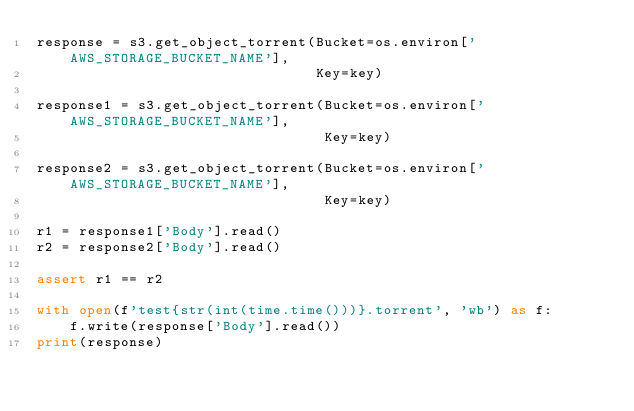<code> <loc_0><loc_0><loc_500><loc_500><_Python_>response = s3.get_object_torrent(Bucket=os.environ['AWS_STORAGE_BUCKET_NAME'],
                                 Key=key)

response1 = s3.get_object_torrent(Bucket=os.environ['AWS_STORAGE_BUCKET_NAME'],
                                  Key=key)

response2 = s3.get_object_torrent(Bucket=os.environ['AWS_STORAGE_BUCKET_NAME'],
                                  Key=key)

r1 = response1['Body'].read()
r2 = response2['Body'].read()

assert r1 == r2

with open(f'test{str(int(time.time()))}.torrent', 'wb') as f:
    f.write(response['Body'].read())
print(response)


</code> 